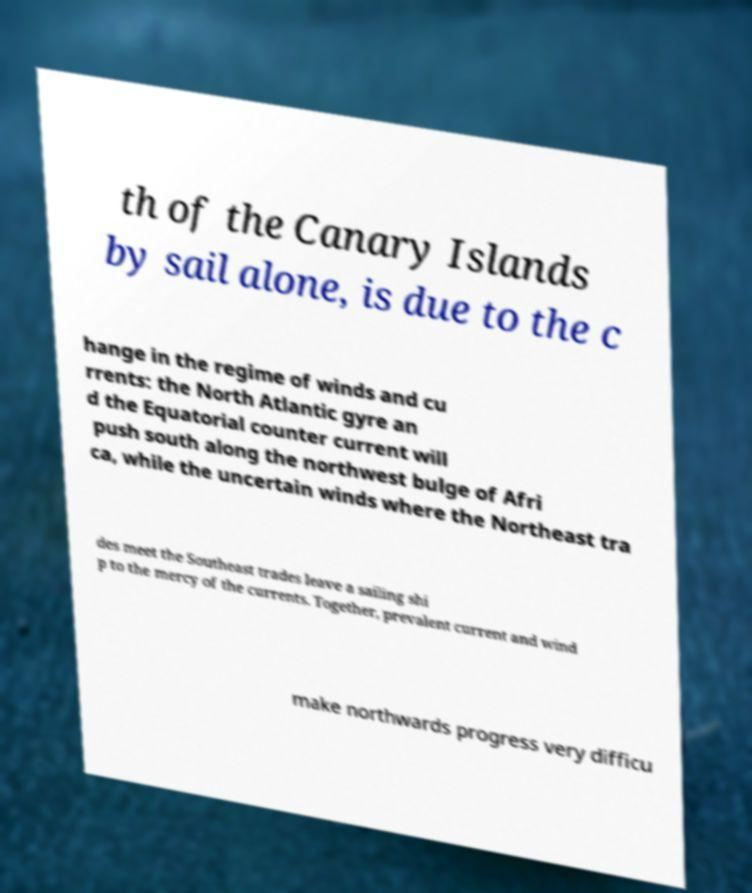Please identify and transcribe the text found in this image. th of the Canary Islands by sail alone, is due to the c hange in the regime of winds and cu rrents: the North Atlantic gyre an d the Equatorial counter current will push south along the northwest bulge of Afri ca, while the uncertain winds where the Northeast tra des meet the Southeast trades leave a sailing shi p to the mercy of the currents. Together, prevalent current and wind make northwards progress very difficu 